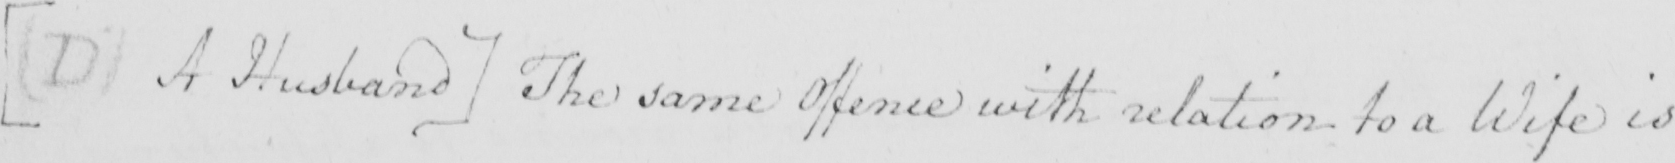What does this handwritten line say? [  ( D )  A Husband ]  The same Offence with relation to a Wife is 